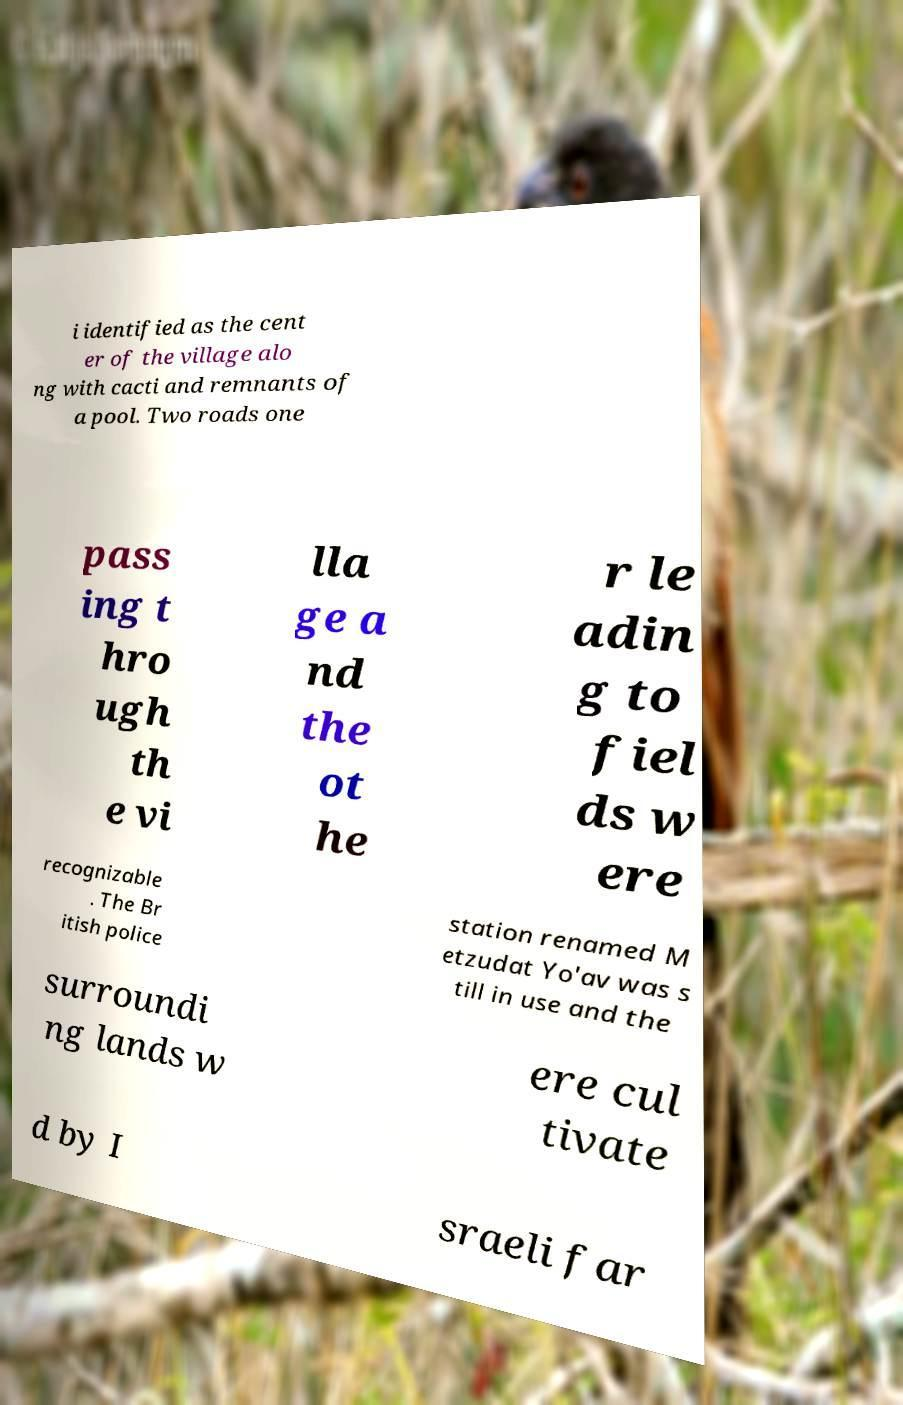Please read and relay the text visible in this image. What does it say? i identified as the cent er of the village alo ng with cacti and remnants of a pool. Two roads one pass ing t hro ugh th e vi lla ge a nd the ot he r le adin g to fiel ds w ere recognizable . The Br itish police station renamed M etzudat Yo'av was s till in use and the surroundi ng lands w ere cul tivate d by I sraeli far 